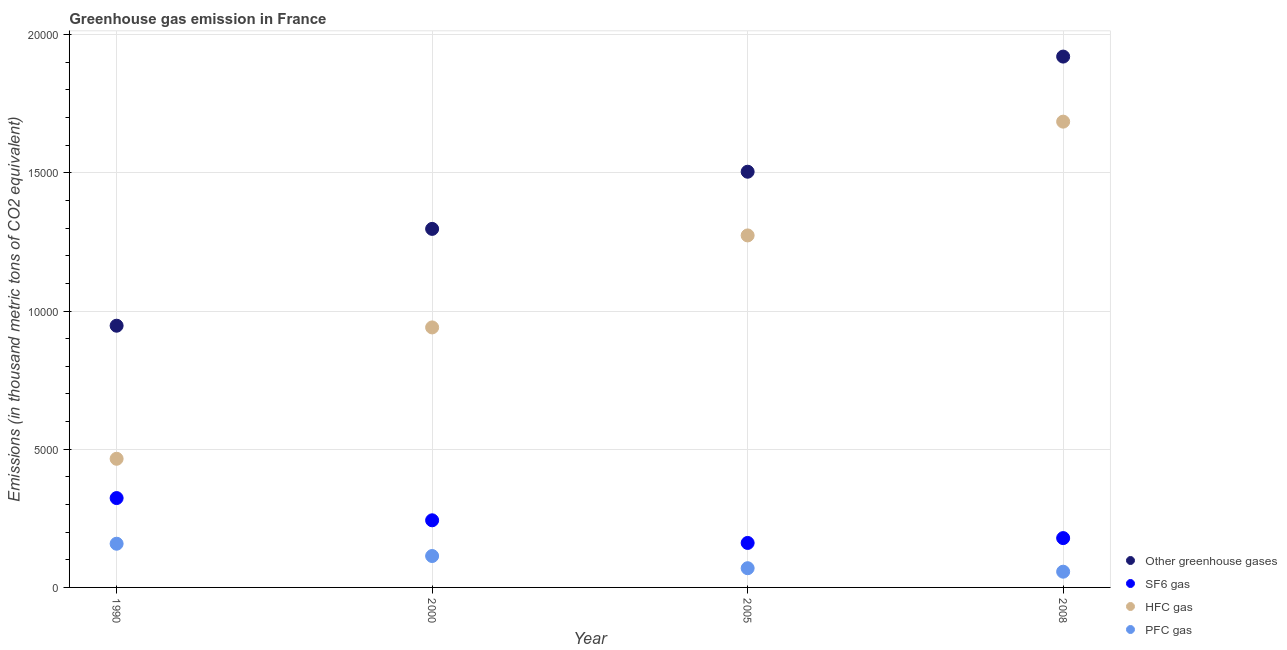How many different coloured dotlines are there?
Ensure brevity in your answer.  4. What is the emission of hfc gas in 2008?
Provide a short and direct response. 1.69e+04. Across all years, what is the maximum emission of hfc gas?
Give a very brief answer. 1.69e+04. Across all years, what is the minimum emission of greenhouse gases?
Offer a terse response. 9468.2. In which year was the emission of hfc gas minimum?
Your answer should be compact. 1990. What is the total emission of pfc gas in the graph?
Your answer should be very brief. 3981.7. What is the difference between the emission of sf6 gas in 2000 and that in 2005?
Your answer should be compact. 819.1. What is the difference between the emission of greenhouse gases in 1990 and the emission of hfc gas in 2008?
Provide a short and direct response. -7382.9. What is the average emission of pfc gas per year?
Offer a very short reply. 995.42. In the year 2008, what is the difference between the emission of greenhouse gases and emission of pfc gas?
Your response must be concise. 1.86e+04. What is the ratio of the emission of sf6 gas in 1990 to that in 2000?
Keep it short and to the point. 1.33. Is the emission of hfc gas in 1990 less than that in 2005?
Offer a very short reply. Yes. Is the difference between the emission of sf6 gas in 1990 and 2000 greater than the difference between the emission of greenhouse gases in 1990 and 2000?
Your answer should be compact. Yes. What is the difference between the highest and the second highest emission of greenhouse gases?
Your answer should be compact. 4165.8. What is the difference between the highest and the lowest emission of greenhouse gases?
Give a very brief answer. 9736.8. In how many years, is the emission of sf6 gas greater than the average emission of sf6 gas taken over all years?
Make the answer very short. 2. Is it the case that in every year, the sum of the emission of hfc gas and emission of sf6 gas is greater than the sum of emission of pfc gas and emission of greenhouse gases?
Offer a terse response. No. Is it the case that in every year, the sum of the emission of greenhouse gases and emission of sf6 gas is greater than the emission of hfc gas?
Provide a succinct answer. Yes. Does the emission of hfc gas monotonically increase over the years?
Make the answer very short. Yes. Is the emission of greenhouse gases strictly greater than the emission of sf6 gas over the years?
Ensure brevity in your answer.  Yes. Is the emission of pfc gas strictly less than the emission of sf6 gas over the years?
Your answer should be very brief. Yes. How many years are there in the graph?
Give a very brief answer. 4. What is the difference between two consecutive major ticks on the Y-axis?
Keep it short and to the point. 5000. Does the graph contain grids?
Ensure brevity in your answer.  Yes. Where does the legend appear in the graph?
Offer a terse response. Bottom right. How many legend labels are there?
Your answer should be very brief. 4. How are the legend labels stacked?
Keep it short and to the point. Vertical. What is the title of the graph?
Offer a terse response. Greenhouse gas emission in France. What is the label or title of the Y-axis?
Your answer should be very brief. Emissions (in thousand metric tons of CO2 equivalent). What is the Emissions (in thousand metric tons of CO2 equivalent) of Other greenhouse gases in 1990?
Ensure brevity in your answer.  9468.2. What is the Emissions (in thousand metric tons of CO2 equivalent) in SF6 gas in 1990?
Offer a terse response. 3232.8. What is the Emissions (in thousand metric tons of CO2 equivalent) in HFC gas in 1990?
Offer a terse response. 4654.3. What is the Emissions (in thousand metric tons of CO2 equivalent) in PFC gas in 1990?
Provide a short and direct response. 1581.1. What is the Emissions (in thousand metric tons of CO2 equivalent) of Other greenhouse gases in 2000?
Ensure brevity in your answer.  1.30e+04. What is the Emissions (in thousand metric tons of CO2 equivalent) in SF6 gas in 2000?
Give a very brief answer. 2428.5. What is the Emissions (in thousand metric tons of CO2 equivalent) in HFC gas in 2000?
Your answer should be very brief. 9406.4. What is the Emissions (in thousand metric tons of CO2 equivalent) in PFC gas in 2000?
Offer a terse response. 1136.3. What is the Emissions (in thousand metric tons of CO2 equivalent) of Other greenhouse gases in 2005?
Your response must be concise. 1.50e+04. What is the Emissions (in thousand metric tons of CO2 equivalent) in SF6 gas in 2005?
Your answer should be very brief. 1609.4. What is the Emissions (in thousand metric tons of CO2 equivalent) in HFC gas in 2005?
Make the answer very short. 1.27e+04. What is the Emissions (in thousand metric tons of CO2 equivalent) of PFC gas in 2005?
Your answer should be very brief. 695.1. What is the Emissions (in thousand metric tons of CO2 equivalent) of Other greenhouse gases in 2008?
Make the answer very short. 1.92e+04. What is the Emissions (in thousand metric tons of CO2 equivalent) of SF6 gas in 2008?
Your answer should be compact. 1784.7. What is the Emissions (in thousand metric tons of CO2 equivalent) of HFC gas in 2008?
Make the answer very short. 1.69e+04. What is the Emissions (in thousand metric tons of CO2 equivalent) of PFC gas in 2008?
Make the answer very short. 569.2. Across all years, what is the maximum Emissions (in thousand metric tons of CO2 equivalent) in Other greenhouse gases?
Your answer should be very brief. 1.92e+04. Across all years, what is the maximum Emissions (in thousand metric tons of CO2 equivalent) in SF6 gas?
Provide a succinct answer. 3232.8. Across all years, what is the maximum Emissions (in thousand metric tons of CO2 equivalent) of HFC gas?
Make the answer very short. 1.69e+04. Across all years, what is the maximum Emissions (in thousand metric tons of CO2 equivalent) of PFC gas?
Your answer should be very brief. 1581.1. Across all years, what is the minimum Emissions (in thousand metric tons of CO2 equivalent) in Other greenhouse gases?
Offer a terse response. 9468.2. Across all years, what is the minimum Emissions (in thousand metric tons of CO2 equivalent) in SF6 gas?
Provide a short and direct response. 1609.4. Across all years, what is the minimum Emissions (in thousand metric tons of CO2 equivalent) of HFC gas?
Your answer should be very brief. 4654.3. Across all years, what is the minimum Emissions (in thousand metric tons of CO2 equivalent) in PFC gas?
Ensure brevity in your answer.  569.2. What is the total Emissions (in thousand metric tons of CO2 equivalent) of Other greenhouse gases in the graph?
Keep it short and to the point. 5.67e+04. What is the total Emissions (in thousand metric tons of CO2 equivalent) of SF6 gas in the graph?
Give a very brief answer. 9055.4. What is the total Emissions (in thousand metric tons of CO2 equivalent) of HFC gas in the graph?
Offer a very short reply. 4.36e+04. What is the total Emissions (in thousand metric tons of CO2 equivalent) of PFC gas in the graph?
Your response must be concise. 3981.7. What is the difference between the Emissions (in thousand metric tons of CO2 equivalent) of Other greenhouse gases in 1990 and that in 2000?
Offer a very short reply. -3503. What is the difference between the Emissions (in thousand metric tons of CO2 equivalent) in SF6 gas in 1990 and that in 2000?
Give a very brief answer. 804.3. What is the difference between the Emissions (in thousand metric tons of CO2 equivalent) of HFC gas in 1990 and that in 2000?
Your answer should be very brief. -4752.1. What is the difference between the Emissions (in thousand metric tons of CO2 equivalent) of PFC gas in 1990 and that in 2000?
Provide a short and direct response. 444.8. What is the difference between the Emissions (in thousand metric tons of CO2 equivalent) in Other greenhouse gases in 1990 and that in 2005?
Your answer should be very brief. -5571. What is the difference between the Emissions (in thousand metric tons of CO2 equivalent) of SF6 gas in 1990 and that in 2005?
Make the answer very short. 1623.4. What is the difference between the Emissions (in thousand metric tons of CO2 equivalent) of HFC gas in 1990 and that in 2005?
Provide a succinct answer. -8080.4. What is the difference between the Emissions (in thousand metric tons of CO2 equivalent) in PFC gas in 1990 and that in 2005?
Ensure brevity in your answer.  886. What is the difference between the Emissions (in thousand metric tons of CO2 equivalent) of Other greenhouse gases in 1990 and that in 2008?
Provide a succinct answer. -9736.8. What is the difference between the Emissions (in thousand metric tons of CO2 equivalent) of SF6 gas in 1990 and that in 2008?
Provide a succinct answer. 1448.1. What is the difference between the Emissions (in thousand metric tons of CO2 equivalent) in HFC gas in 1990 and that in 2008?
Your answer should be compact. -1.22e+04. What is the difference between the Emissions (in thousand metric tons of CO2 equivalent) in PFC gas in 1990 and that in 2008?
Provide a succinct answer. 1011.9. What is the difference between the Emissions (in thousand metric tons of CO2 equivalent) in Other greenhouse gases in 2000 and that in 2005?
Give a very brief answer. -2068. What is the difference between the Emissions (in thousand metric tons of CO2 equivalent) of SF6 gas in 2000 and that in 2005?
Offer a very short reply. 819.1. What is the difference between the Emissions (in thousand metric tons of CO2 equivalent) in HFC gas in 2000 and that in 2005?
Give a very brief answer. -3328.3. What is the difference between the Emissions (in thousand metric tons of CO2 equivalent) of PFC gas in 2000 and that in 2005?
Provide a succinct answer. 441.2. What is the difference between the Emissions (in thousand metric tons of CO2 equivalent) in Other greenhouse gases in 2000 and that in 2008?
Give a very brief answer. -6233.8. What is the difference between the Emissions (in thousand metric tons of CO2 equivalent) of SF6 gas in 2000 and that in 2008?
Your answer should be very brief. 643.8. What is the difference between the Emissions (in thousand metric tons of CO2 equivalent) in HFC gas in 2000 and that in 2008?
Ensure brevity in your answer.  -7444.7. What is the difference between the Emissions (in thousand metric tons of CO2 equivalent) of PFC gas in 2000 and that in 2008?
Make the answer very short. 567.1. What is the difference between the Emissions (in thousand metric tons of CO2 equivalent) of Other greenhouse gases in 2005 and that in 2008?
Provide a succinct answer. -4165.8. What is the difference between the Emissions (in thousand metric tons of CO2 equivalent) in SF6 gas in 2005 and that in 2008?
Offer a very short reply. -175.3. What is the difference between the Emissions (in thousand metric tons of CO2 equivalent) of HFC gas in 2005 and that in 2008?
Ensure brevity in your answer.  -4116.4. What is the difference between the Emissions (in thousand metric tons of CO2 equivalent) of PFC gas in 2005 and that in 2008?
Your answer should be compact. 125.9. What is the difference between the Emissions (in thousand metric tons of CO2 equivalent) of Other greenhouse gases in 1990 and the Emissions (in thousand metric tons of CO2 equivalent) of SF6 gas in 2000?
Provide a succinct answer. 7039.7. What is the difference between the Emissions (in thousand metric tons of CO2 equivalent) of Other greenhouse gases in 1990 and the Emissions (in thousand metric tons of CO2 equivalent) of HFC gas in 2000?
Your answer should be very brief. 61.8. What is the difference between the Emissions (in thousand metric tons of CO2 equivalent) of Other greenhouse gases in 1990 and the Emissions (in thousand metric tons of CO2 equivalent) of PFC gas in 2000?
Provide a succinct answer. 8331.9. What is the difference between the Emissions (in thousand metric tons of CO2 equivalent) of SF6 gas in 1990 and the Emissions (in thousand metric tons of CO2 equivalent) of HFC gas in 2000?
Keep it short and to the point. -6173.6. What is the difference between the Emissions (in thousand metric tons of CO2 equivalent) in SF6 gas in 1990 and the Emissions (in thousand metric tons of CO2 equivalent) in PFC gas in 2000?
Provide a succinct answer. 2096.5. What is the difference between the Emissions (in thousand metric tons of CO2 equivalent) in HFC gas in 1990 and the Emissions (in thousand metric tons of CO2 equivalent) in PFC gas in 2000?
Offer a terse response. 3518. What is the difference between the Emissions (in thousand metric tons of CO2 equivalent) in Other greenhouse gases in 1990 and the Emissions (in thousand metric tons of CO2 equivalent) in SF6 gas in 2005?
Provide a short and direct response. 7858.8. What is the difference between the Emissions (in thousand metric tons of CO2 equivalent) in Other greenhouse gases in 1990 and the Emissions (in thousand metric tons of CO2 equivalent) in HFC gas in 2005?
Make the answer very short. -3266.5. What is the difference between the Emissions (in thousand metric tons of CO2 equivalent) in Other greenhouse gases in 1990 and the Emissions (in thousand metric tons of CO2 equivalent) in PFC gas in 2005?
Keep it short and to the point. 8773.1. What is the difference between the Emissions (in thousand metric tons of CO2 equivalent) of SF6 gas in 1990 and the Emissions (in thousand metric tons of CO2 equivalent) of HFC gas in 2005?
Give a very brief answer. -9501.9. What is the difference between the Emissions (in thousand metric tons of CO2 equivalent) in SF6 gas in 1990 and the Emissions (in thousand metric tons of CO2 equivalent) in PFC gas in 2005?
Ensure brevity in your answer.  2537.7. What is the difference between the Emissions (in thousand metric tons of CO2 equivalent) in HFC gas in 1990 and the Emissions (in thousand metric tons of CO2 equivalent) in PFC gas in 2005?
Ensure brevity in your answer.  3959.2. What is the difference between the Emissions (in thousand metric tons of CO2 equivalent) of Other greenhouse gases in 1990 and the Emissions (in thousand metric tons of CO2 equivalent) of SF6 gas in 2008?
Your answer should be very brief. 7683.5. What is the difference between the Emissions (in thousand metric tons of CO2 equivalent) in Other greenhouse gases in 1990 and the Emissions (in thousand metric tons of CO2 equivalent) in HFC gas in 2008?
Your answer should be very brief. -7382.9. What is the difference between the Emissions (in thousand metric tons of CO2 equivalent) of Other greenhouse gases in 1990 and the Emissions (in thousand metric tons of CO2 equivalent) of PFC gas in 2008?
Make the answer very short. 8899. What is the difference between the Emissions (in thousand metric tons of CO2 equivalent) in SF6 gas in 1990 and the Emissions (in thousand metric tons of CO2 equivalent) in HFC gas in 2008?
Ensure brevity in your answer.  -1.36e+04. What is the difference between the Emissions (in thousand metric tons of CO2 equivalent) in SF6 gas in 1990 and the Emissions (in thousand metric tons of CO2 equivalent) in PFC gas in 2008?
Your answer should be very brief. 2663.6. What is the difference between the Emissions (in thousand metric tons of CO2 equivalent) in HFC gas in 1990 and the Emissions (in thousand metric tons of CO2 equivalent) in PFC gas in 2008?
Your answer should be very brief. 4085.1. What is the difference between the Emissions (in thousand metric tons of CO2 equivalent) in Other greenhouse gases in 2000 and the Emissions (in thousand metric tons of CO2 equivalent) in SF6 gas in 2005?
Ensure brevity in your answer.  1.14e+04. What is the difference between the Emissions (in thousand metric tons of CO2 equivalent) in Other greenhouse gases in 2000 and the Emissions (in thousand metric tons of CO2 equivalent) in HFC gas in 2005?
Provide a short and direct response. 236.5. What is the difference between the Emissions (in thousand metric tons of CO2 equivalent) in Other greenhouse gases in 2000 and the Emissions (in thousand metric tons of CO2 equivalent) in PFC gas in 2005?
Your answer should be compact. 1.23e+04. What is the difference between the Emissions (in thousand metric tons of CO2 equivalent) of SF6 gas in 2000 and the Emissions (in thousand metric tons of CO2 equivalent) of HFC gas in 2005?
Offer a terse response. -1.03e+04. What is the difference between the Emissions (in thousand metric tons of CO2 equivalent) of SF6 gas in 2000 and the Emissions (in thousand metric tons of CO2 equivalent) of PFC gas in 2005?
Your answer should be very brief. 1733.4. What is the difference between the Emissions (in thousand metric tons of CO2 equivalent) in HFC gas in 2000 and the Emissions (in thousand metric tons of CO2 equivalent) in PFC gas in 2005?
Offer a terse response. 8711.3. What is the difference between the Emissions (in thousand metric tons of CO2 equivalent) of Other greenhouse gases in 2000 and the Emissions (in thousand metric tons of CO2 equivalent) of SF6 gas in 2008?
Provide a succinct answer. 1.12e+04. What is the difference between the Emissions (in thousand metric tons of CO2 equivalent) of Other greenhouse gases in 2000 and the Emissions (in thousand metric tons of CO2 equivalent) of HFC gas in 2008?
Ensure brevity in your answer.  -3879.9. What is the difference between the Emissions (in thousand metric tons of CO2 equivalent) of Other greenhouse gases in 2000 and the Emissions (in thousand metric tons of CO2 equivalent) of PFC gas in 2008?
Offer a terse response. 1.24e+04. What is the difference between the Emissions (in thousand metric tons of CO2 equivalent) in SF6 gas in 2000 and the Emissions (in thousand metric tons of CO2 equivalent) in HFC gas in 2008?
Ensure brevity in your answer.  -1.44e+04. What is the difference between the Emissions (in thousand metric tons of CO2 equivalent) in SF6 gas in 2000 and the Emissions (in thousand metric tons of CO2 equivalent) in PFC gas in 2008?
Your answer should be compact. 1859.3. What is the difference between the Emissions (in thousand metric tons of CO2 equivalent) in HFC gas in 2000 and the Emissions (in thousand metric tons of CO2 equivalent) in PFC gas in 2008?
Offer a very short reply. 8837.2. What is the difference between the Emissions (in thousand metric tons of CO2 equivalent) of Other greenhouse gases in 2005 and the Emissions (in thousand metric tons of CO2 equivalent) of SF6 gas in 2008?
Ensure brevity in your answer.  1.33e+04. What is the difference between the Emissions (in thousand metric tons of CO2 equivalent) of Other greenhouse gases in 2005 and the Emissions (in thousand metric tons of CO2 equivalent) of HFC gas in 2008?
Give a very brief answer. -1811.9. What is the difference between the Emissions (in thousand metric tons of CO2 equivalent) of Other greenhouse gases in 2005 and the Emissions (in thousand metric tons of CO2 equivalent) of PFC gas in 2008?
Ensure brevity in your answer.  1.45e+04. What is the difference between the Emissions (in thousand metric tons of CO2 equivalent) in SF6 gas in 2005 and the Emissions (in thousand metric tons of CO2 equivalent) in HFC gas in 2008?
Your answer should be compact. -1.52e+04. What is the difference between the Emissions (in thousand metric tons of CO2 equivalent) of SF6 gas in 2005 and the Emissions (in thousand metric tons of CO2 equivalent) of PFC gas in 2008?
Keep it short and to the point. 1040.2. What is the difference between the Emissions (in thousand metric tons of CO2 equivalent) in HFC gas in 2005 and the Emissions (in thousand metric tons of CO2 equivalent) in PFC gas in 2008?
Provide a short and direct response. 1.22e+04. What is the average Emissions (in thousand metric tons of CO2 equivalent) of Other greenhouse gases per year?
Give a very brief answer. 1.42e+04. What is the average Emissions (in thousand metric tons of CO2 equivalent) of SF6 gas per year?
Your answer should be compact. 2263.85. What is the average Emissions (in thousand metric tons of CO2 equivalent) of HFC gas per year?
Offer a terse response. 1.09e+04. What is the average Emissions (in thousand metric tons of CO2 equivalent) of PFC gas per year?
Keep it short and to the point. 995.42. In the year 1990, what is the difference between the Emissions (in thousand metric tons of CO2 equivalent) of Other greenhouse gases and Emissions (in thousand metric tons of CO2 equivalent) of SF6 gas?
Provide a succinct answer. 6235.4. In the year 1990, what is the difference between the Emissions (in thousand metric tons of CO2 equivalent) in Other greenhouse gases and Emissions (in thousand metric tons of CO2 equivalent) in HFC gas?
Provide a short and direct response. 4813.9. In the year 1990, what is the difference between the Emissions (in thousand metric tons of CO2 equivalent) in Other greenhouse gases and Emissions (in thousand metric tons of CO2 equivalent) in PFC gas?
Ensure brevity in your answer.  7887.1. In the year 1990, what is the difference between the Emissions (in thousand metric tons of CO2 equivalent) in SF6 gas and Emissions (in thousand metric tons of CO2 equivalent) in HFC gas?
Your response must be concise. -1421.5. In the year 1990, what is the difference between the Emissions (in thousand metric tons of CO2 equivalent) in SF6 gas and Emissions (in thousand metric tons of CO2 equivalent) in PFC gas?
Provide a succinct answer. 1651.7. In the year 1990, what is the difference between the Emissions (in thousand metric tons of CO2 equivalent) of HFC gas and Emissions (in thousand metric tons of CO2 equivalent) of PFC gas?
Make the answer very short. 3073.2. In the year 2000, what is the difference between the Emissions (in thousand metric tons of CO2 equivalent) of Other greenhouse gases and Emissions (in thousand metric tons of CO2 equivalent) of SF6 gas?
Offer a very short reply. 1.05e+04. In the year 2000, what is the difference between the Emissions (in thousand metric tons of CO2 equivalent) of Other greenhouse gases and Emissions (in thousand metric tons of CO2 equivalent) of HFC gas?
Your answer should be very brief. 3564.8. In the year 2000, what is the difference between the Emissions (in thousand metric tons of CO2 equivalent) of Other greenhouse gases and Emissions (in thousand metric tons of CO2 equivalent) of PFC gas?
Offer a very short reply. 1.18e+04. In the year 2000, what is the difference between the Emissions (in thousand metric tons of CO2 equivalent) in SF6 gas and Emissions (in thousand metric tons of CO2 equivalent) in HFC gas?
Your response must be concise. -6977.9. In the year 2000, what is the difference between the Emissions (in thousand metric tons of CO2 equivalent) in SF6 gas and Emissions (in thousand metric tons of CO2 equivalent) in PFC gas?
Give a very brief answer. 1292.2. In the year 2000, what is the difference between the Emissions (in thousand metric tons of CO2 equivalent) in HFC gas and Emissions (in thousand metric tons of CO2 equivalent) in PFC gas?
Give a very brief answer. 8270.1. In the year 2005, what is the difference between the Emissions (in thousand metric tons of CO2 equivalent) of Other greenhouse gases and Emissions (in thousand metric tons of CO2 equivalent) of SF6 gas?
Your response must be concise. 1.34e+04. In the year 2005, what is the difference between the Emissions (in thousand metric tons of CO2 equivalent) of Other greenhouse gases and Emissions (in thousand metric tons of CO2 equivalent) of HFC gas?
Keep it short and to the point. 2304.5. In the year 2005, what is the difference between the Emissions (in thousand metric tons of CO2 equivalent) of Other greenhouse gases and Emissions (in thousand metric tons of CO2 equivalent) of PFC gas?
Your response must be concise. 1.43e+04. In the year 2005, what is the difference between the Emissions (in thousand metric tons of CO2 equivalent) of SF6 gas and Emissions (in thousand metric tons of CO2 equivalent) of HFC gas?
Keep it short and to the point. -1.11e+04. In the year 2005, what is the difference between the Emissions (in thousand metric tons of CO2 equivalent) in SF6 gas and Emissions (in thousand metric tons of CO2 equivalent) in PFC gas?
Offer a very short reply. 914.3. In the year 2005, what is the difference between the Emissions (in thousand metric tons of CO2 equivalent) in HFC gas and Emissions (in thousand metric tons of CO2 equivalent) in PFC gas?
Offer a terse response. 1.20e+04. In the year 2008, what is the difference between the Emissions (in thousand metric tons of CO2 equivalent) of Other greenhouse gases and Emissions (in thousand metric tons of CO2 equivalent) of SF6 gas?
Give a very brief answer. 1.74e+04. In the year 2008, what is the difference between the Emissions (in thousand metric tons of CO2 equivalent) in Other greenhouse gases and Emissions (in thousand metric tons of CO2 equivalent) in HFC gas?
Make the answer very short. 2353.9. In the year 2008, what is the difference between the Emissions (in thousand metric tons of CO2 equivalent) of Other greenhouse gases and Emissions (in thousand metric tons of CO2 equivalent) of PFC gas?
Provide a succinct answer. 1.86e+04. In the year 2008, what is the difference between the Emissions (in thousand metric tons of CO2 equivalent) of SF6 gas and Emissions (in thousand metric tons of CO2 equivalent) of HFC gas?
Provide a succinct answer. -1.51e+04. In the year 2008, what is the difference between the Emissions (in thousand metric tons of CO2 equivalent) of SF6 gas and Emissions (in thousand metric tons of CO2 equivalent) of PFC gas?
Offer a very short reply. 1215.5. In the year 2008, what is the difference between the Emissions (in thousand metric tons of CO2 equivalent) of HFC gas and Emissions (in thousand metric tons of CO2 equivalent) of PFC gas?
Offer a terse response. 1.63e+04. What is the ratio of the Emissions (in thousand metric tons of CO2 equivalent) of Other greenhouse gases in 1990 to that in 2000?
Give a very brief answer. 0.73. What is the ratio of the Emissions (in thousand metric tons of CO2 equivalent) in SF6 gas in 1990 to that in 2000?
Make the answer very short. 1.33. What is the ratio of the Emissions (in thousand metric tons of CO2 equivalent) of HFC gas in 1990 to that in 2000?
Your response must be concise. 0.49. What is the ratio of the Emissions (in thousand metric tons of CO2 equivalent) of PFC gas in 1990 to that in 2000?
Provide a short and direct response. 1.39. What is the ratio of the Emissions (in thousand metric tons of CO2 equivalent) in Other greenhouse gases in 1990 to that in 2005?
Your answer should be very brief. 0.63. What is the ratio of the Emissions (in thousand metric tons of CO2 equivalent) of SF6 gas in 1990 to that in 2005?
Your answer should be very brief. 2.01. What is the ratio of the Emissions (in thousand metric tons of CO2 equivalent) of HFC gas in 1990 to that in 2005?
Give a very brief answer. 0.37. What is the ratio of the Emissions (in thousand metric tons of CO2 equivalent) of PFC gas in 1990 to that in 2005?
Your answer should be compact. 2.27. What is the ratio of the Emissions (in thousand metric tons of CO2 equivalent) in Other greenhouse gases in 1990 to that in 2008?
Provide a succinct answer. 0.49. What is the ratio of the Emissions (in thousand metric tons of CO2 equivalent) in SF6 gas in 1990 to that in 2008?
Your response must be concise. 1.81. What is the ratio of the Emissions (in thousand metric tons of CO2 equivalent) of HFC gas in 1990 to that in 2008?
Give a very brief answer. 0.28. What is the ratio of the Emissions (in thousand metric tons of CO2 equivalent) of PFC gas in 1990 to that in 2008?
Give a very brief answer. 2.78. What is the ratio of the Emissions (in thousand metric tons of CO2 equivalent) in Other greenhouse gases in 2000 to that in 2005?
Give a very brief answer. 0.86. What is the ratio of the Emissions (in thousand metric tons of CO2 equivalent) of SF6 gas in 2000 to that in 2005?
Your answer should be compact. 1.51. What is the ratio of the Emissions (in thousand metric tons of CO2 equivalent) of HFC gas in 2000 to that in 2005?
Ensure brevity in your answer.  0.74. What is the ratio of the Emissions (in thousand metric tons of CO2 equivalent) of PFC gas in 2000 to that in 2005?
Make the answer very short. 1.63. What is the ratio of the Emissions (in thousand metric tons of CO2 equivalent) in Other greenhouse gases in 2000 to that in 2008?
Ensure brevity in your answer.  0.68. What is the ratio of the Emissions (in thousand metric tons of CO2 equivalent) of SF6 gas in 2000 to that in 2008?
Your answer should be compact. 1.36. What is the ratio of the Emissions (in thousand metric tons of CO2 equivalent) of HFC gas in 2000 to that in 2008?
Offer a terse response. 0.56. What is the ratio of the Emissions (in thousand metric tons of CO2 equivalent) of PFC gas in 2000 to that in 2008?
Your response must be concise. 2. What is the ratio of the Emissions (in thousand metric tons of CO2 equivalent) of Other greenhouse gases in 2005 to that in 2008?
Your answer should be very brief. 0.78. What is the ratio of the Emissions (in thousand metric tons of CO2 equivalent) of SF6 gas in 2005 to that in 2008?
Provide a short and direct response. 0.9. What is the ratio of the Emissions (in thousand metric tons of CO2 equivalent) of HFC gas in 2005 to that in 2008?
Ensure brevity in your answer.  0.76. What is the ratio of the Emissions (in thousand metric tons of CO2 equivalent) of PFC gas in 2005 to that in 2008?
Your response must be concise. 1.22. What is the difference between the highest and the second highest Emissions (in thousand metric tons of CO2 equivalent) in Other greenhouse gases?
Your response must be concise. 4165.8. What is the difference between the highest and the second highest Emissions (in thousand metric tons of CO2 equivalent) of SF6 gas?
Give a very brief answer. 804.3. What is the difference between the highest and the second highest Emissions (in thousand metric tons of CO2 equivalent) of HFC gas?
Ensure brevity in your answer.  4116.4. What is the difference between the highest and the second highest Emissions (in thousand metric tons of CO2 equivalent) in PFC gas?
Provide a short and direct response. 444.8. What is the difference between the highest and the lowest Emissions (in thousand metric tons of CO2 equivalent) of Other greenhouse gases?
Your response must be concise. 9736.8. What is the difference between the highest and the lowest Emissions (in thousand metric tons of CO2 equivalent) in SF6 gas?
Keep it short and to the point. 1623.4. What is the difference between the highest and the lowest Emissions (in thousand metric tons of CO2 equivalent) of HFC gas?
Your answer should be very brief. 1.22e+04. What is the difference between the highest and the lowest Emissions (in thousand metric tons of CO2 equivalent) of PFC gas?
Offer a very short reply. 1011.9. 